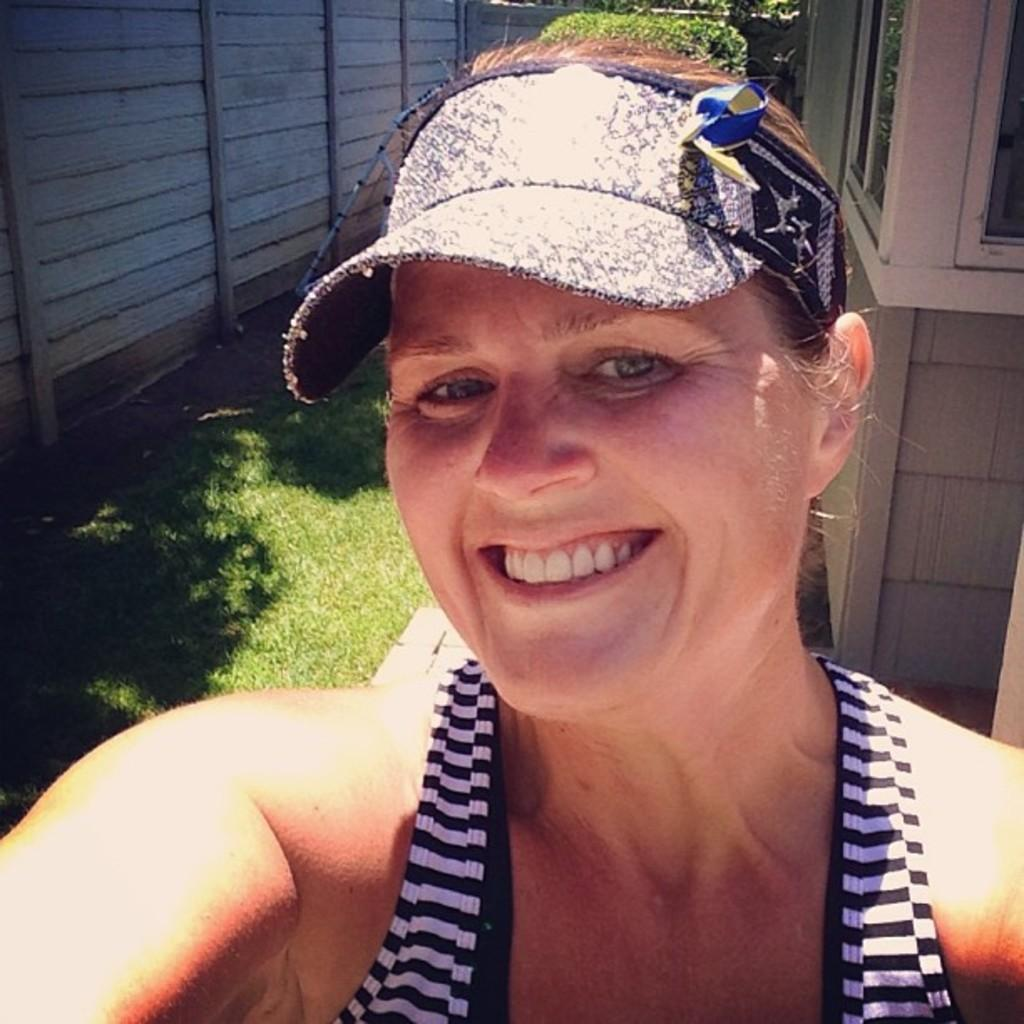Who is present in the image? There is a woman in the image. What is the woman's facial expression? The woman is smiling. What type of surface is visible behind the woman? There is grass on the surface behind the woman. What type of barrier is present in the image? There is a wooden fence in the image. Where is the library located in the image? There is no library present in the image. What time of day is it in the image, considering the position of the sun? The position of the sun is not visible in the image, so it cannot be determined from the image alone. 